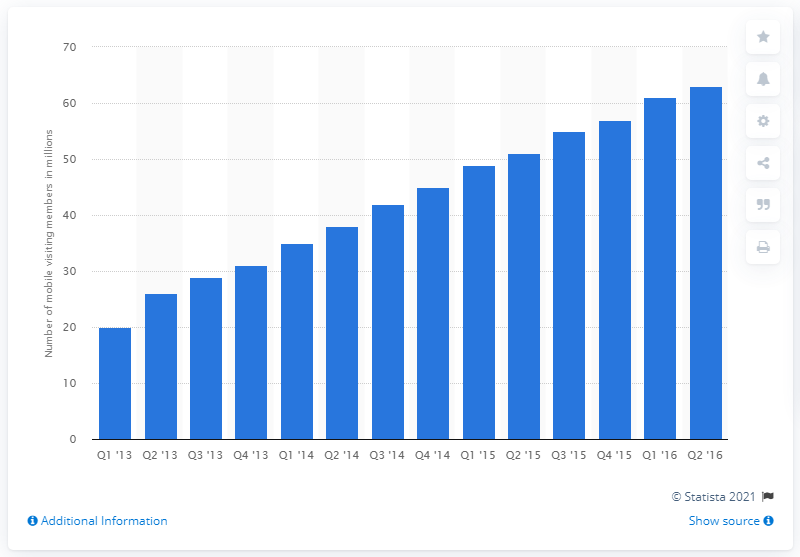Point out several critical features in this image. As of the second quarter of 2016, LinkedIn had an average of approximately 63 unique mobile visitors per month. 